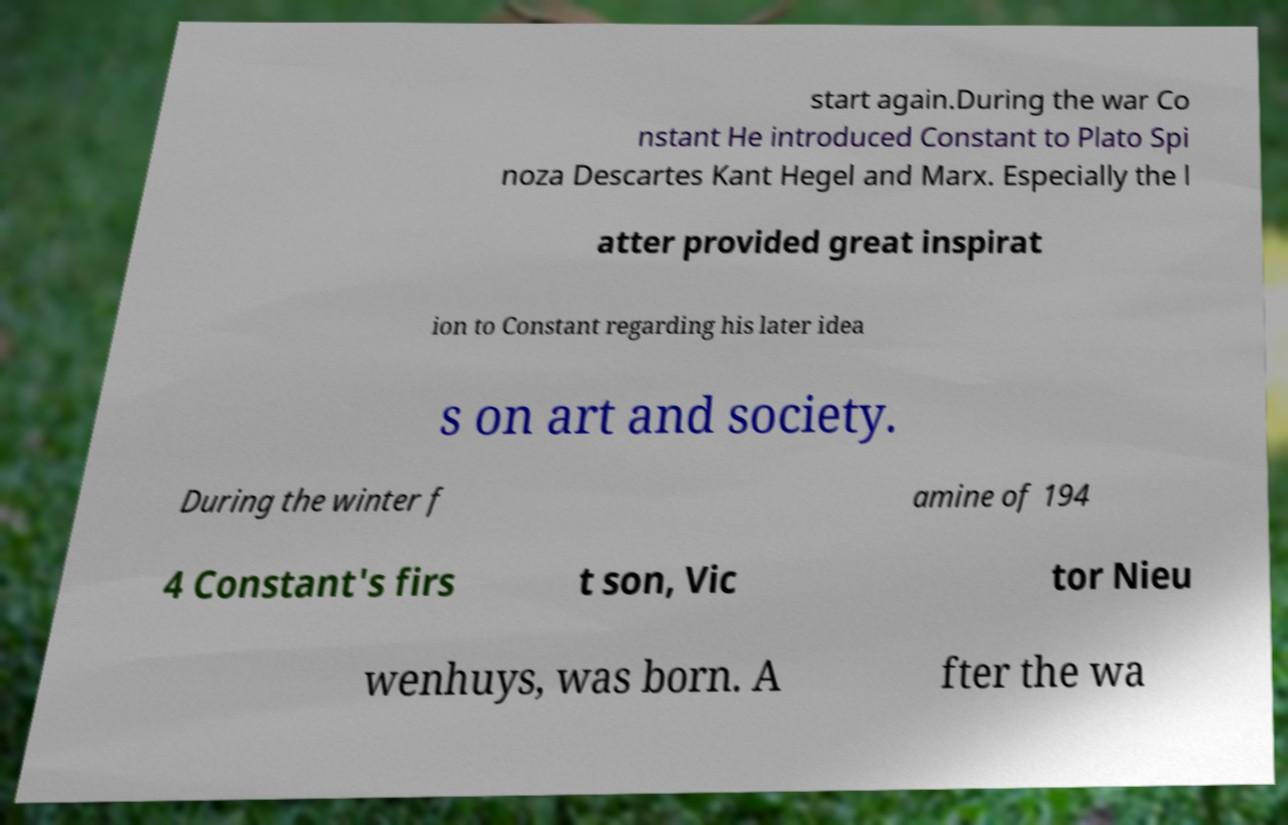Could you assist in decoding the text presented in this image and type it out clearly? start again.During the war Co nstant He introduced Constant to Plato Spi noza Descartes Kant Hegel and Marx. Especially the l atter provided great inspirat ion to Constant regarding his later idea s on art and society. During the winter f amine of 194 4 Constant's firs t son, Vic tor Nieu wenhuys, was born. A fter the wa 